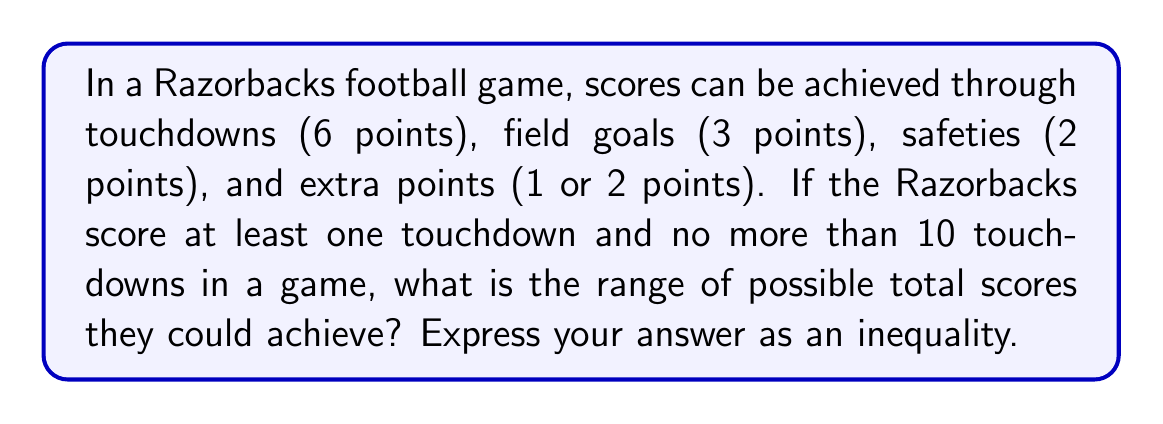Teach me how to tackle this problem. Let's approach this step-by-step:

1) Minimum score:
   - At least one touchdown: 6 points
   - Minimum total: 6 points

2) Maximum score:
   - Maximum 10 touchdowns: $10 \times 6 = 60$ points
   - For each touchdown, they could score a 2-point conversion: $10 \times 2 = 20$ points
   - They could also score field goals and safeties in addition to touchdowns
   - There's no theoretical upper limit, but practically, scores rarely exceed 100 points

3) Range calculation:
   - Lower bound: 6 points
   - Upper bound: No definite upper bound, but we can represent it as $x$

4) Expressing as an inequality:
   $$6 \leq \text{Razorbacks Score} \leq x$$

   Where $x$ represents the theoretical maximum score, which is undefined but practically limited.

5) In reality, $x$ could be considered around 100 for a very high-scoring game, but the question doesn't specify a fixed upper limit.
Answer: $6 \leq \text{Razorbacks Score} \leq x$, where $x$ is the undefined upper limit 